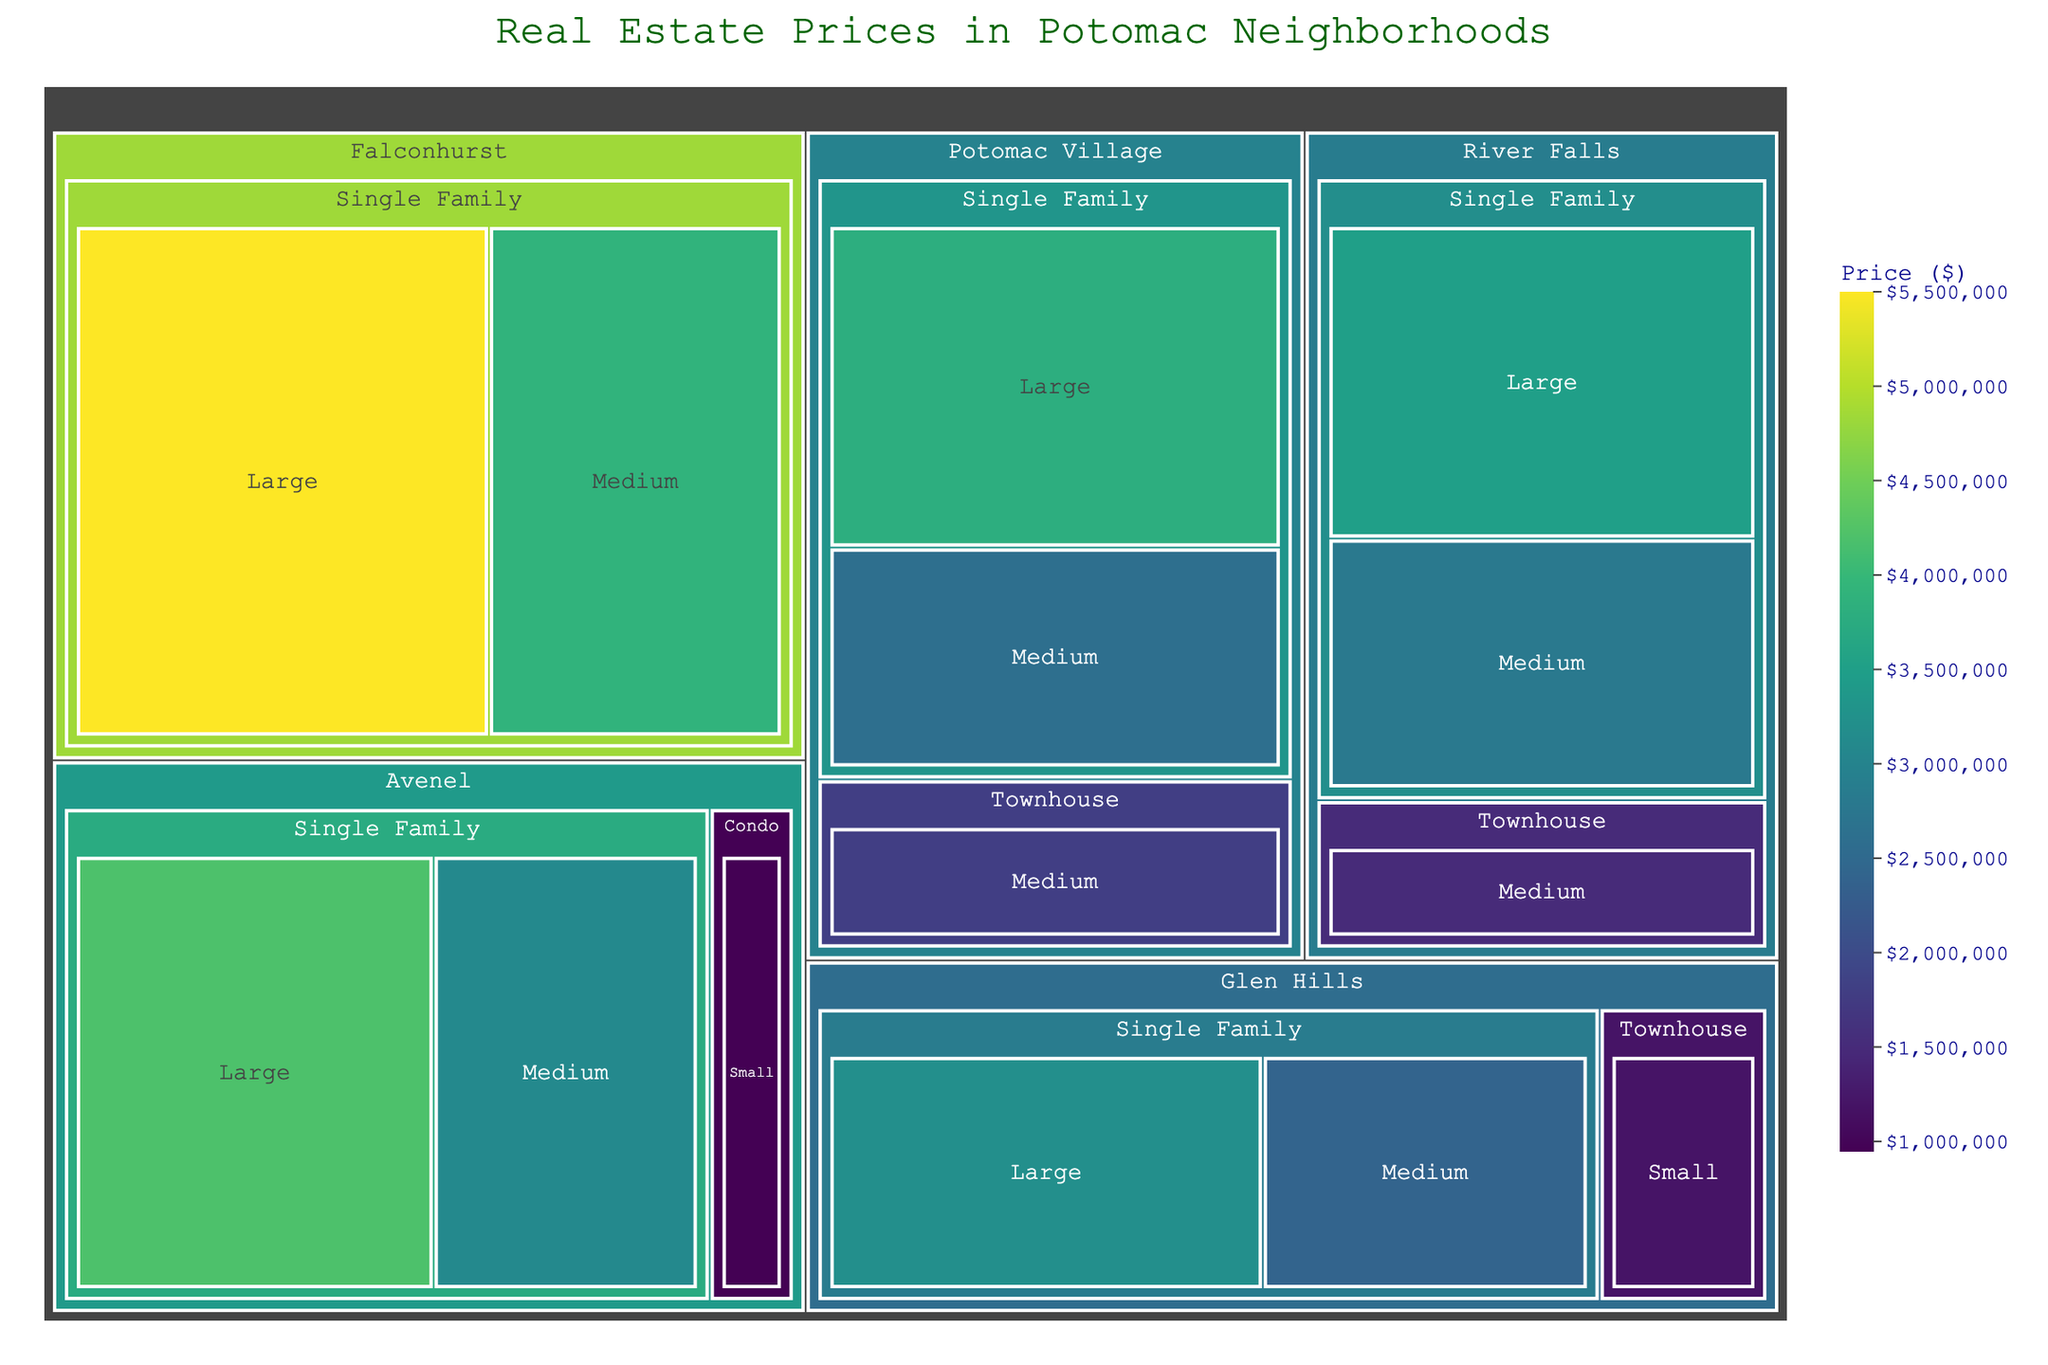What's the title of the treemap? The title is usually located at the top center of the figure. By reading the title text, you can identify the theme of the plot.
Answer: Real Estate Prices in Potomac Neighborhoods Which neighborhood has the highest priced single-family large property? Observing the 'Single Family' category under 'Large' properties, the price bars can be compared among neighborhoods to find the highest value.
Answer: Falconhurst How much more expensive is the most costly large single-family home compared to the least expensive large single-family home? Identify the most and least expensive large single-family home prices from the color-coded value bars and subtract the lesser from the greater value.
Answer: $2,300,000 Which neighborhood has the widest range of property types and sizes? Review each neighborhood to evaluate the variety of property types and sizes indicated. The neighborhood with the most distinct categories displayed has the widest range.
Answer: Avenel Which property type has the highest average price in Potomac Village? Calculate the average price for each property type in Potomac Village by summing the prices and dividing by the number of data points in each type. Compare these averages to identify the highest one.
Answer: Single Family What is the total combined value of medium-sized townhouses across all neighborhoods? Sum the prices for all medium-sized townhouses by identifying the relevant data points in each neighborhood and adding them up.
Answer: $3,300,000 What color scale is used to represent the prices? The color gradient used in the figure represents another data dimension. Carefully examining the legend or color bar helps identify the specific color scale name.
Answer: Viridis Which neighborhood has the largest difference between the highest and lowest priced properties? Determine the highest and lowest prices within each neighborhood by checking the color and values for properties, then calculate the price difference and compare it across neighborhoods.
Answer: Falconhurst What is the median price for a medium-sized single-family home in River Falls? Arrange the prices of medium-sized single-family homes within River Falls in ascending order and find the middle value, as this represents the median.
Answer: $2,800,000 Which neighborhood has properties of all three types: Single Family, Townhouse, and Condo? Review the properties listed within each neighborhood to determine if all three types are present. Compare neighborhoods accordingly.
Answer: Avenel 